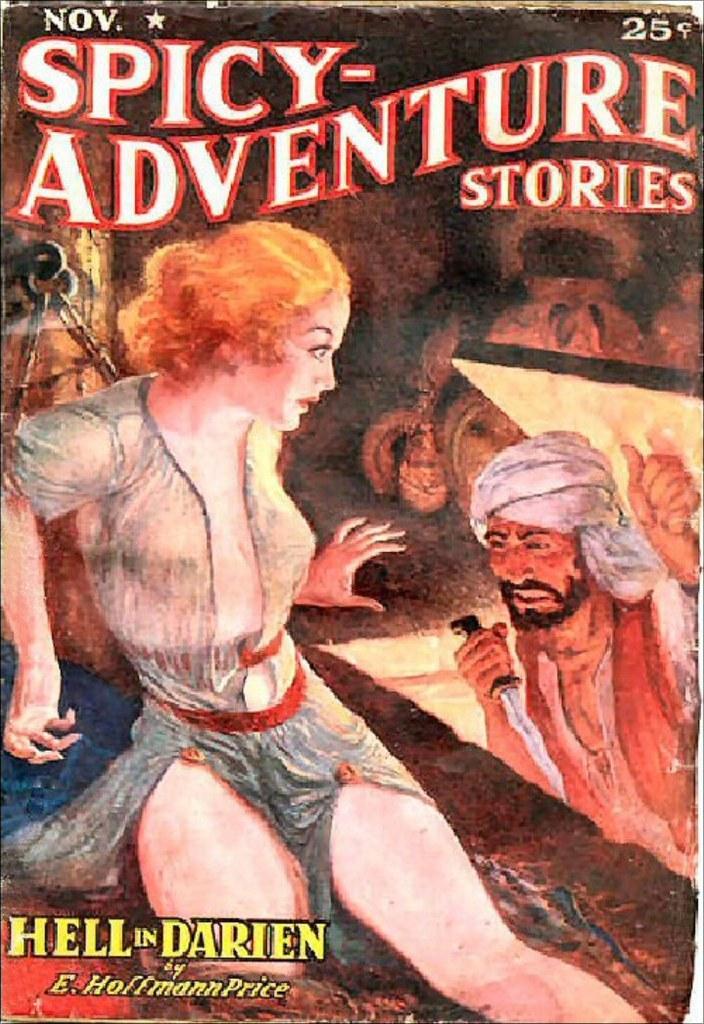Could you give a brief overview of what you see in this image? In the foreground of this picture there is a drawing of a woman seems to be sitting on the ground. On the right there is a picture of a man holding a knife. In the background there are some items and we can see the text on the image. 